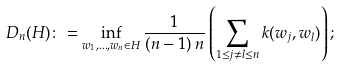Convert formula to latex. <formula><loc_0><loc_0><loc_500><loc_500>D _ { n } ( H ) \colon = \inf _ { w _ { 1 } , \dots , w _ { n } \in H } { \frac { 1 } { ( n - 1 ) \, n } } \left ( \sum _ { 1 \leq j \neq l \leq n } k ( w _ { j } , w _ { l } ) \right ) ;</formula> 